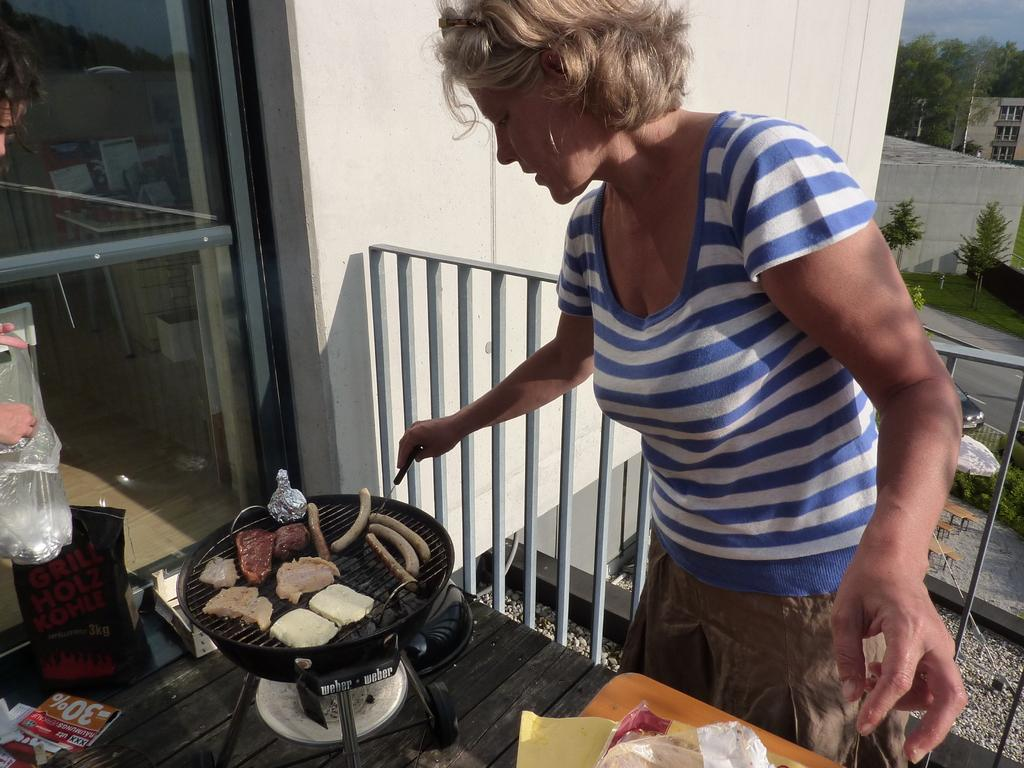<image>
Share a concise interpretation of the image provided. A woman grills sausages, meats and chicken on a Weber grill. 